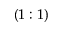Convert formula to latex. <formula><loc_0><loc_0><loc_500><loc_500>( 1 \colon 1 )</formula> 